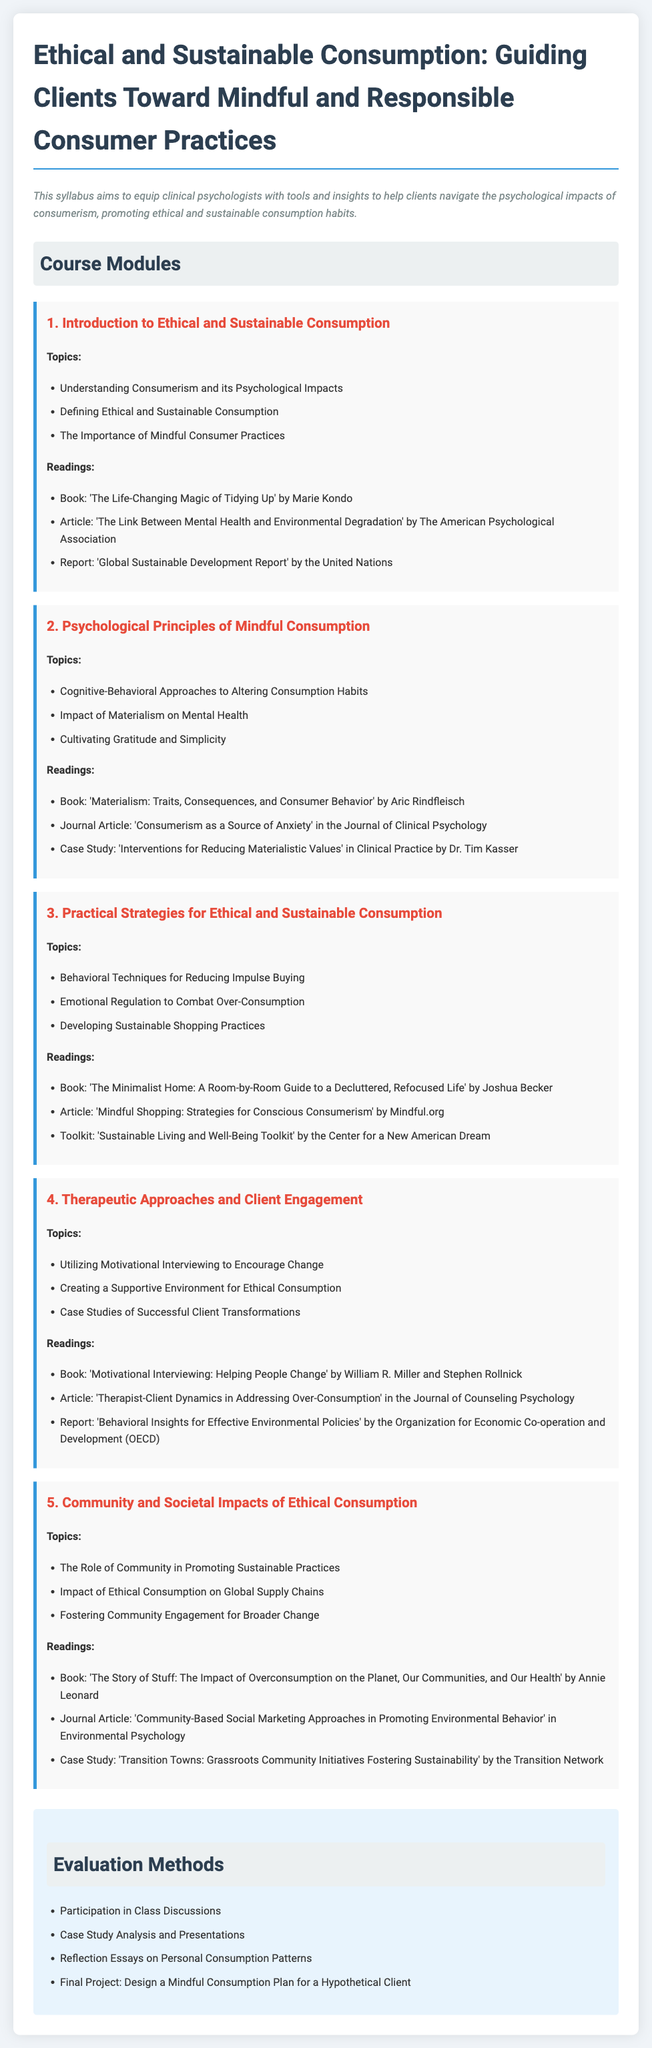What is the title of the syllabus? The title is specified at the top of the document and describes the focus on consumption practices.
Answer: Ethical and Sustainable Consumption: Guiding Clients Toward Mindful and Responsible Consumer Practices How many course modules are there? The number of course modules is listed in the "Course Modules" section as separate topics.
Answer: 5 Who is the author of the book 'The Life-Changing Magic of Tidying Up'? The author of a book mentioned in the readings section is directly cited.
Answer: Marie Kondo What therapeutic approach is highlighted for encouraging change in clients? The document specifies a method used for engaging clients in a supportive way towards sustainability.
Answer: Motivational Interviewing Which book covers the impact of overconsumption on health and communities? This book is identified in the readings, emphasizing the societal impact of consumer habits.
Answer: The Story of Stuff: The Impact of Overconsumption on the Planet, Our Communities, and Our Health What type of evaluation method is included in the syllabus? The evaluation methods are outlined in a dedicated section and include different assessment strategies.
Answer: Reflection Essays on Personal Consumption Patterns What is one emotional regulation strategy mentioned in the syllabus? The syllabus lists specific topics under practical strategies that address consumption behavior.
Answer: Emotional Regulation to Combat Over-Consumption Which publication addresses consumerism's impact on mental health? This journal article is cited within the readings associated with a specific module.
Answer: Consumerism as a Source of Anxiety How many readings are listed for the module on Practical Strategies for Ethical and Sustainable Consumption? The document specifies individual readings for each module clearly indicating the number.
Answer: 3 